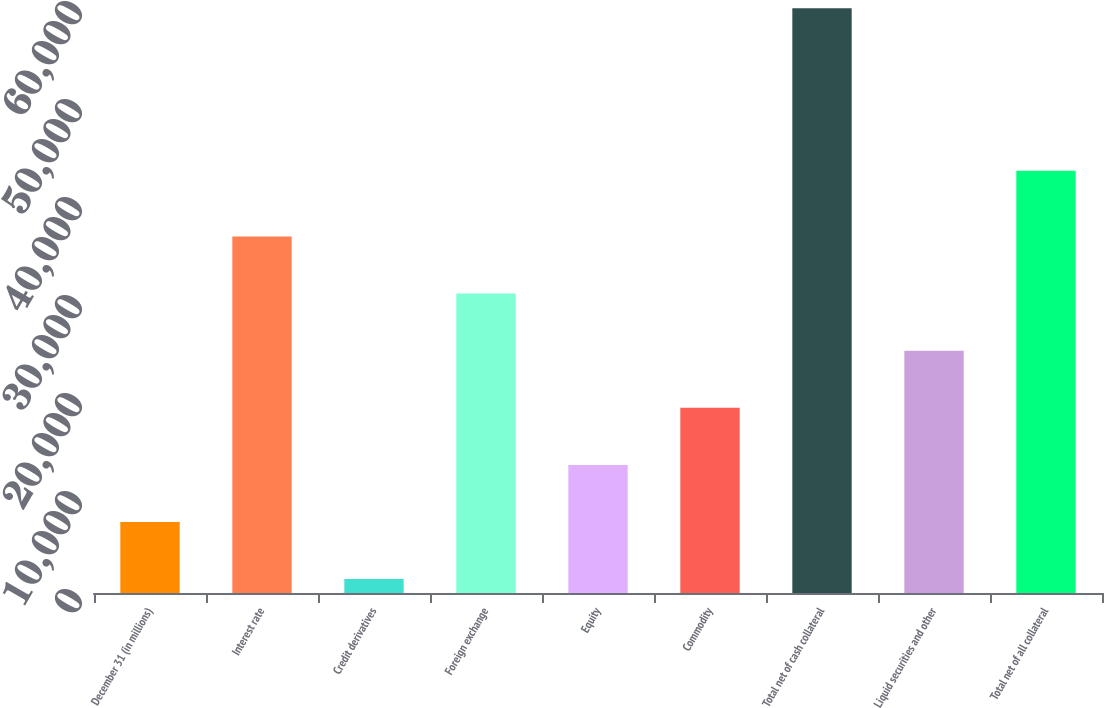<chart> <loc_0><loc_0><loc_500><loc_500><bar_chart><fcel>December 31 (in millions)<fcel>Interest rate<fcel>Credit derivatives<fcel>Foreign exchange<fcel>Equity<fcel>Commodity<fcel>Total net of cash collateral<fcel>Liquid securities and other<fcel>Total net of all collateral<nl><fcel>7248.4<fcel>36375.4<fcel>1423<fcel>30550<fcel>13073.8<fcel>18899.2<fcel>59677<fcel>24724.6<fcel>43097<nl></chart> 